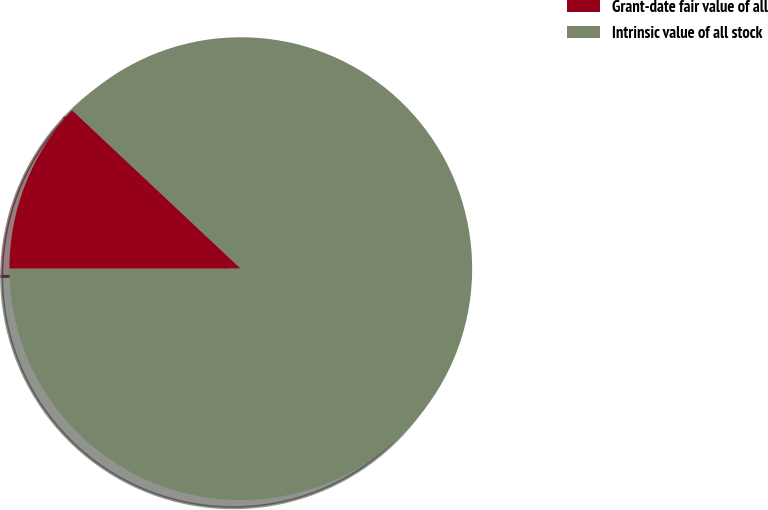<chart> <loc_0><loc_0><loc_500><loc_500><pie_chart><fcel>Grant-date fair value of all<fcel>Intrinsic value of all stock<nl><fcel>12.01%<fcel>87.99%<nl></chart> 